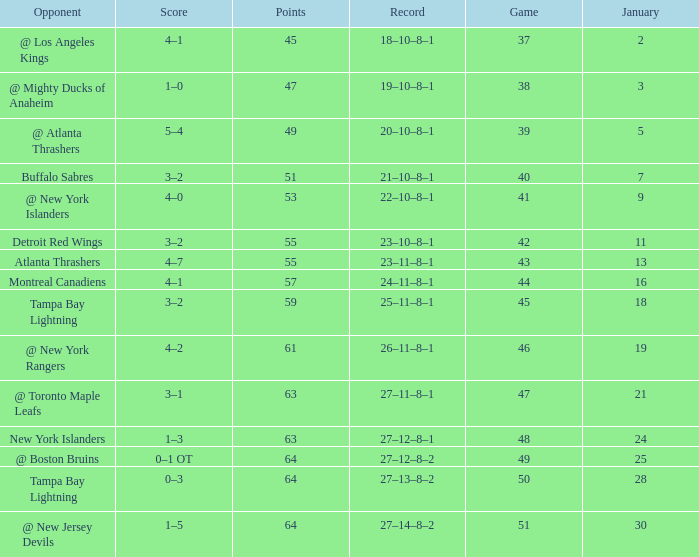Which Points have a Score of 4–1, and a Record of 18–10–8–1, and a January larger than 2? None. 